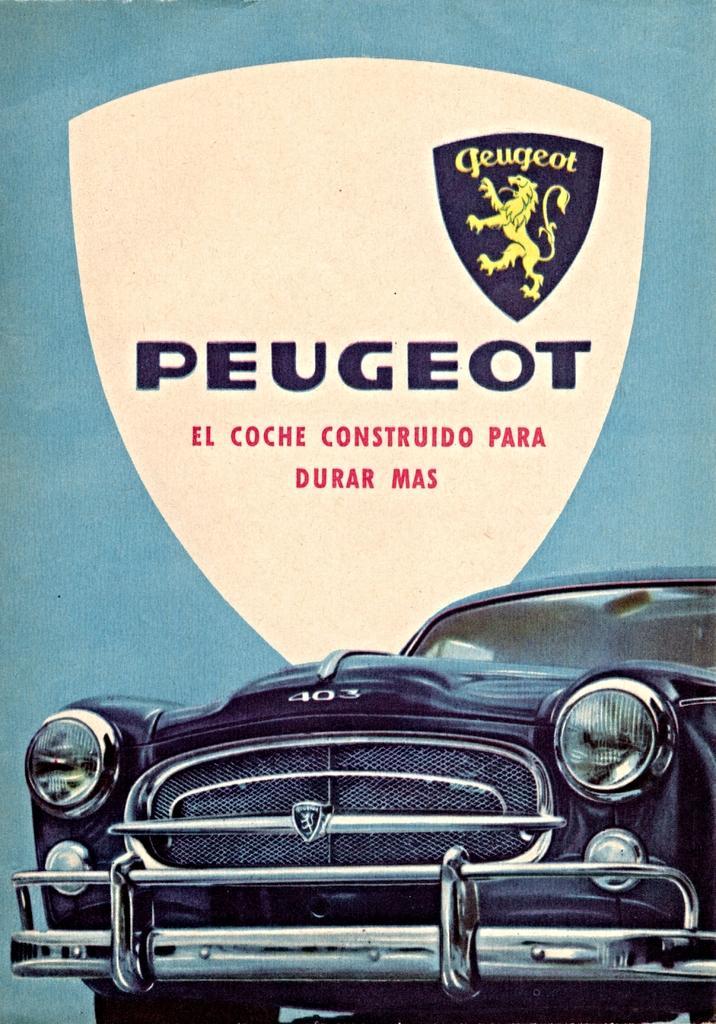In one or two sentences, can you explain what this image depicts? This is an edited image. In the foreground we can see the picture of a car seems to be parked on the ground. In the background we can see the text and the picture of an animal on the blue color banner. 